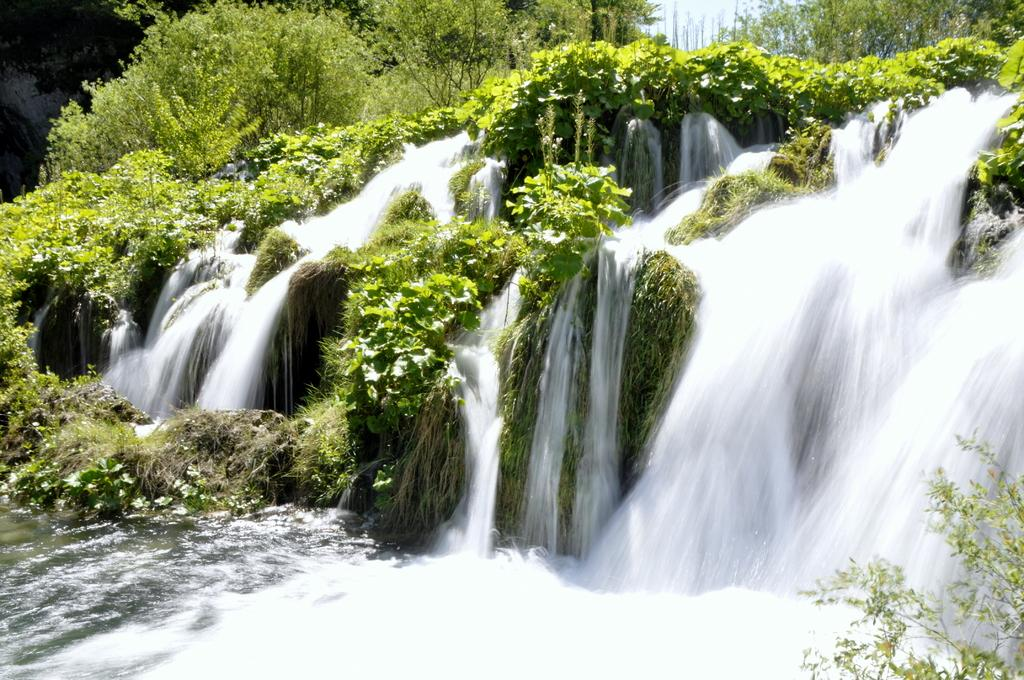What natural feature is the main subject of the image? There is a waterfall in the image. What other natural elements can be seen in the image? There is a group of trees in the image. What can be seen in the background of the image? The sky is visible in the background of the image. What type of dress is the grandfather wearing in the image? There is no grandfather or dress present in the image; it features a waterfall and a group of trees. 